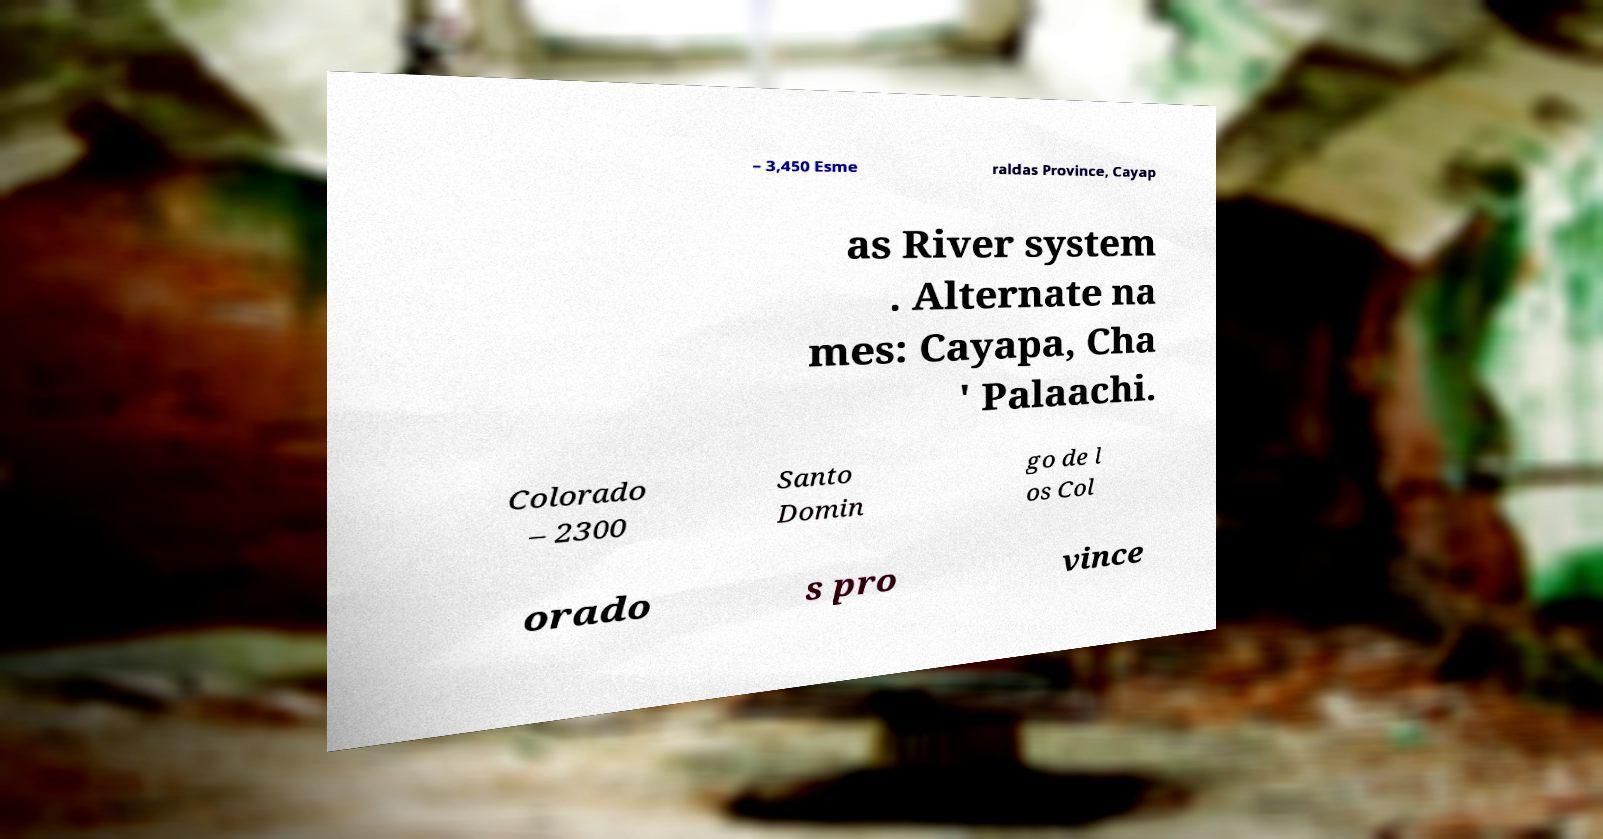For documentation purposes, I need the text within this image transcribed. Could you provide that? – 3,450 Esme raldas Province, Cayap as River system . Alternate na mes: Cayapa, Cha ' Palaachi. Colorado – 2300 Santo Domin go de l os Col orado s pro vince 